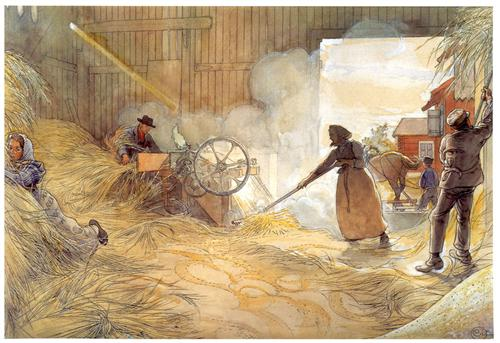If animals could observe this scene, what might one of them think? If an animal, say a barn cat, were observing this scene, it might perceive a sense of routine and predictability in the humans' activities. The cat would note the rhythmic nature of their movements and the steady hum of work, feeling a sense of calm from the familiarity of these daily tasks. The humans' actions, while energetic and deliberate, appear harmonious and practiced, creating an environment that feels stable and safe for the observing animal. The cat might find a cozy spot in the hay, basking in the warmth and watching the scene unfold with silent curiosity. 